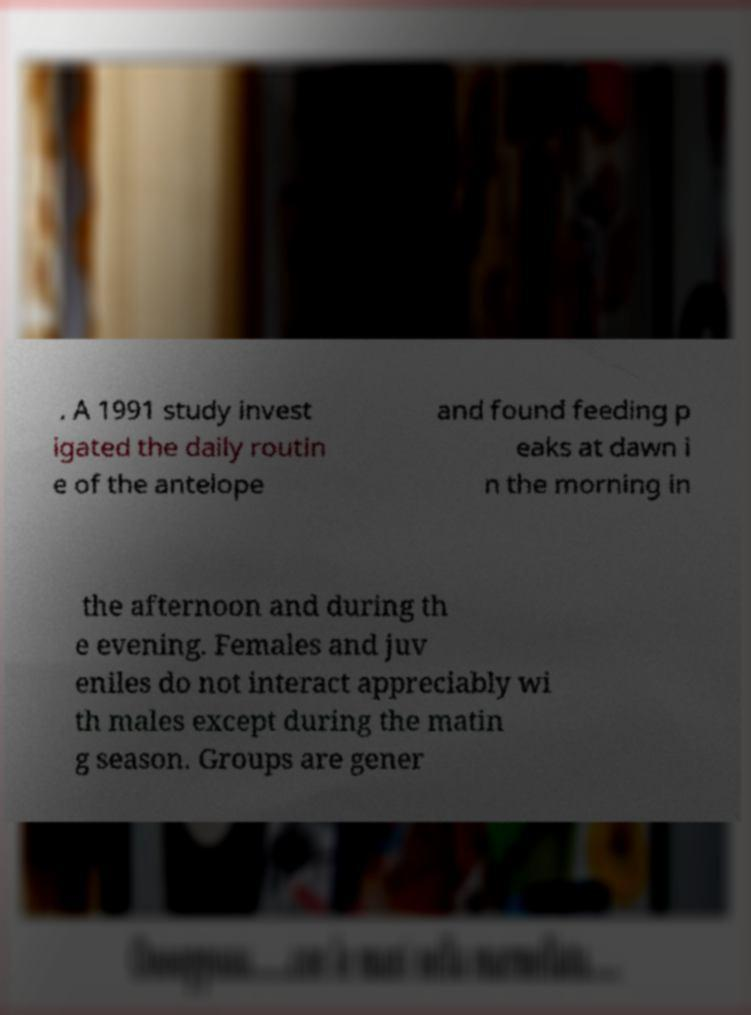For documentation purposes, I need the text within this image transcribed. Could you provide that? . A 1991 study invest igated the daily routin e of the antelope and found feeding p eaks at dawn i n the morning in the afternoon and during th e evening. Females and juv eniles do not interact appreciably wi th males except during the matin g season. Groups are gener 